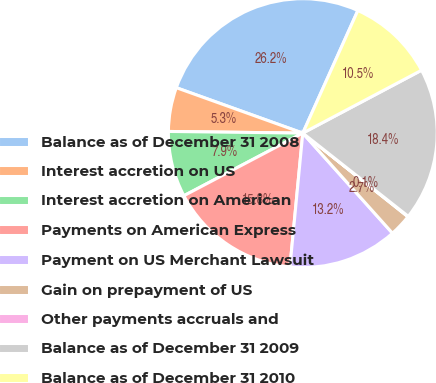<chart> <loc_0><loc_0><loc_500><loc_500><pie_chart><fcel>Balance as of December 31 2008<fcel>Interest accretion on US<fcel>Interest accretion on American<fcel>Payments on American Express<fcel>Payment on US Merchant Lawsuit<fcel>Gain on prepayment of US<fcel>Other payments accruals and<fcel>Balance as of December 31 2009<fcel>Balance as of December 31 2010<nl><fcel>26.23%<fcel>5.29%<fcel>7.91%<fcel>15.76%<fcel>13.15%<fcel>2.68%<fcel>0.06%<fcel>18.38%<fcel>10.53%<nl></chart> 